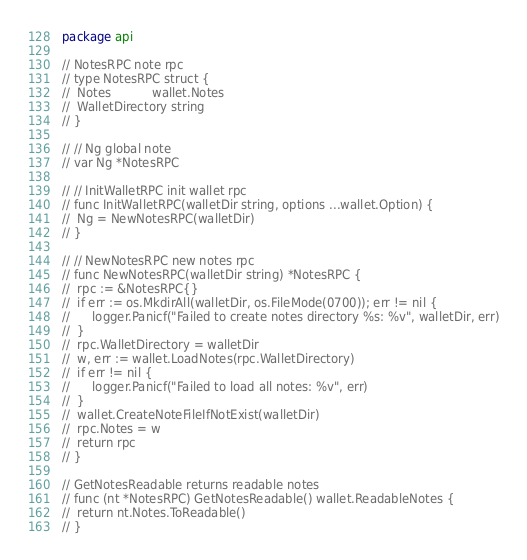Convert code to text. <code><loc_0><loc_0><loc_500><loc_500><_Go_>package api

// NotesRPC note rpc
// type NotesRPC struct {
// 	Notes           wallet.Notes
// 	WalletDirectory string
// }

// // Ng global note
// var Ng *NotesRPC

// // InitWalletRPC init wallet rpc
// func InitWalletRPC(walletDir string, options ...wallet.Option) {
// 	Ng = NewNotesRPC(walletDir)
// }

// // NewNotesRPC new notes rpc
// func NewNotesRPC(walletDir string) *NotesRPC {
// 	rpc := &NotesRPC{}
// 	if err := os.MkdirAll(walletDir, os.FileMode(0700)); err != nil {
// 		logger.Panicf("Failed to create notes directory %s: %v", walletDir, err)
// 	}
// 	rpc.WalletDirectory = walletDir
// 	w, err := wallet.LoadNotes(rpc.WalletDirectory)
// 	if err != nil {
// 		logger.Panicf("Failed to load all notes: %v", err)
// 	}
// 	wallet.CreateNoteFileIfNotExist(walletDir)
// 	rpc.Notes = w
// 	return rpc
// }

// GetNotesReadable returns readable notes
// func (nt *NotesRPC) GetNotesReadable() wallet.ReadableNotes {
// 	return nt.Notes.ToReadable()
// }
</code> 